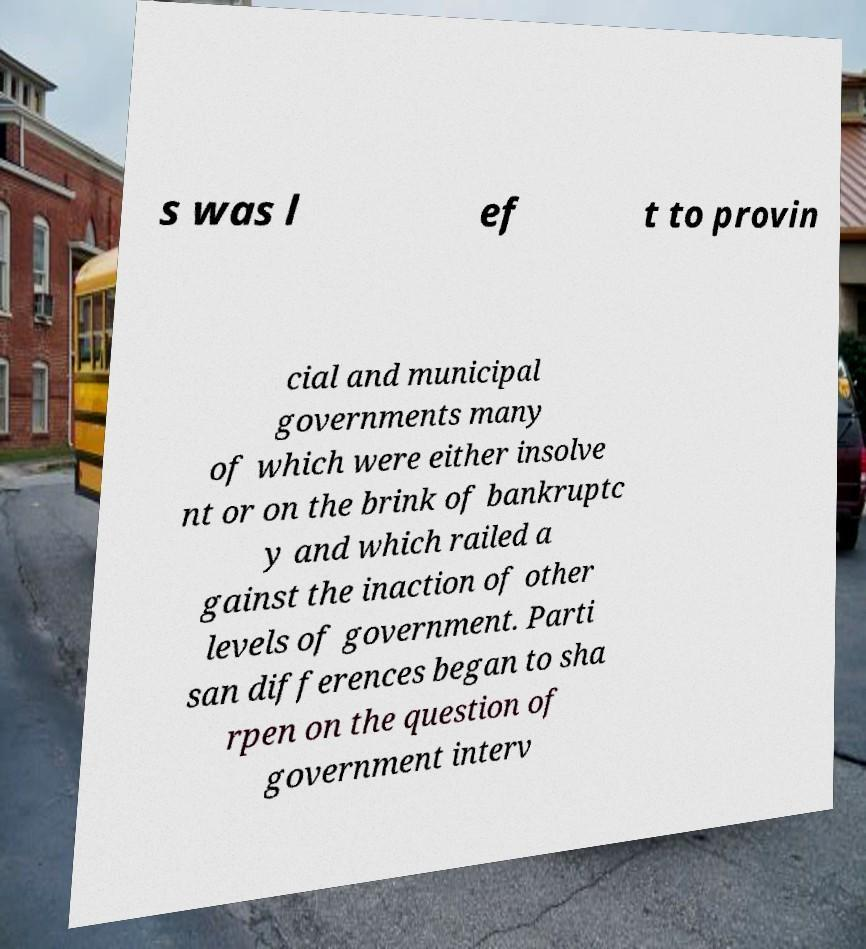There's text embedded in this image that I need extracted. Can you transcribe it verbatim? s was l ef t to provin cial and municipal governments many of which were either insolve nt or on the brink of bankruptc y and which railed a gainst the inaction of other levels of government. Parti san differences began to sha rpen on the question of government interv 